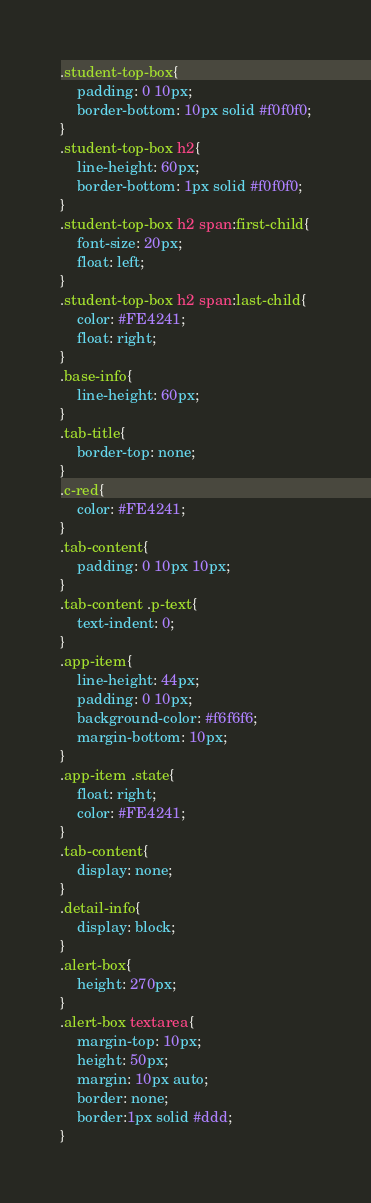<code> <loc_0><loc_0><loc_500><loc_500><_CSS_>.student-top-box{
    padding: 0 10px;
    border-bottom: 10px solid #f0f0f0;
}
.student-top-box h2{
    line-height: 60px;
    border-bottom: 1px solid #f0f0f0;
}
.student-top-box h2 span:first-child{
    font-size: 20px;
    float: left;
}
.student-top-box h2 span:last-child{
    color: #FE4241;
    float: right;
}
.base-info{
    line-height: 60px;
}
.tab-title{
    border-top: none;
}
.c-red{
    color: #FE4241;
}
.tab-content{
    padding: 0 10px 10px;
}
.tab-content .p-text{
    text-indent: 0;
}
.app-item{
    line-height: 44px;
    padding: 0 10px;
    background-color: #f6f6f6;
    margin-bottom: 10px;
}
.app-item .state{
    float: right;
    color: #FE4241;
}
.tab-content{
    display: none;
}
.detail-info{
    display: block;
}
.alert-box{
    height: 270px;
}
.alert-box textarea{
    margin-top: 10px;
    height: 50px;
    margin: 10px auto;
    border: none;
    border:1px solid #ddd;
}</code> 